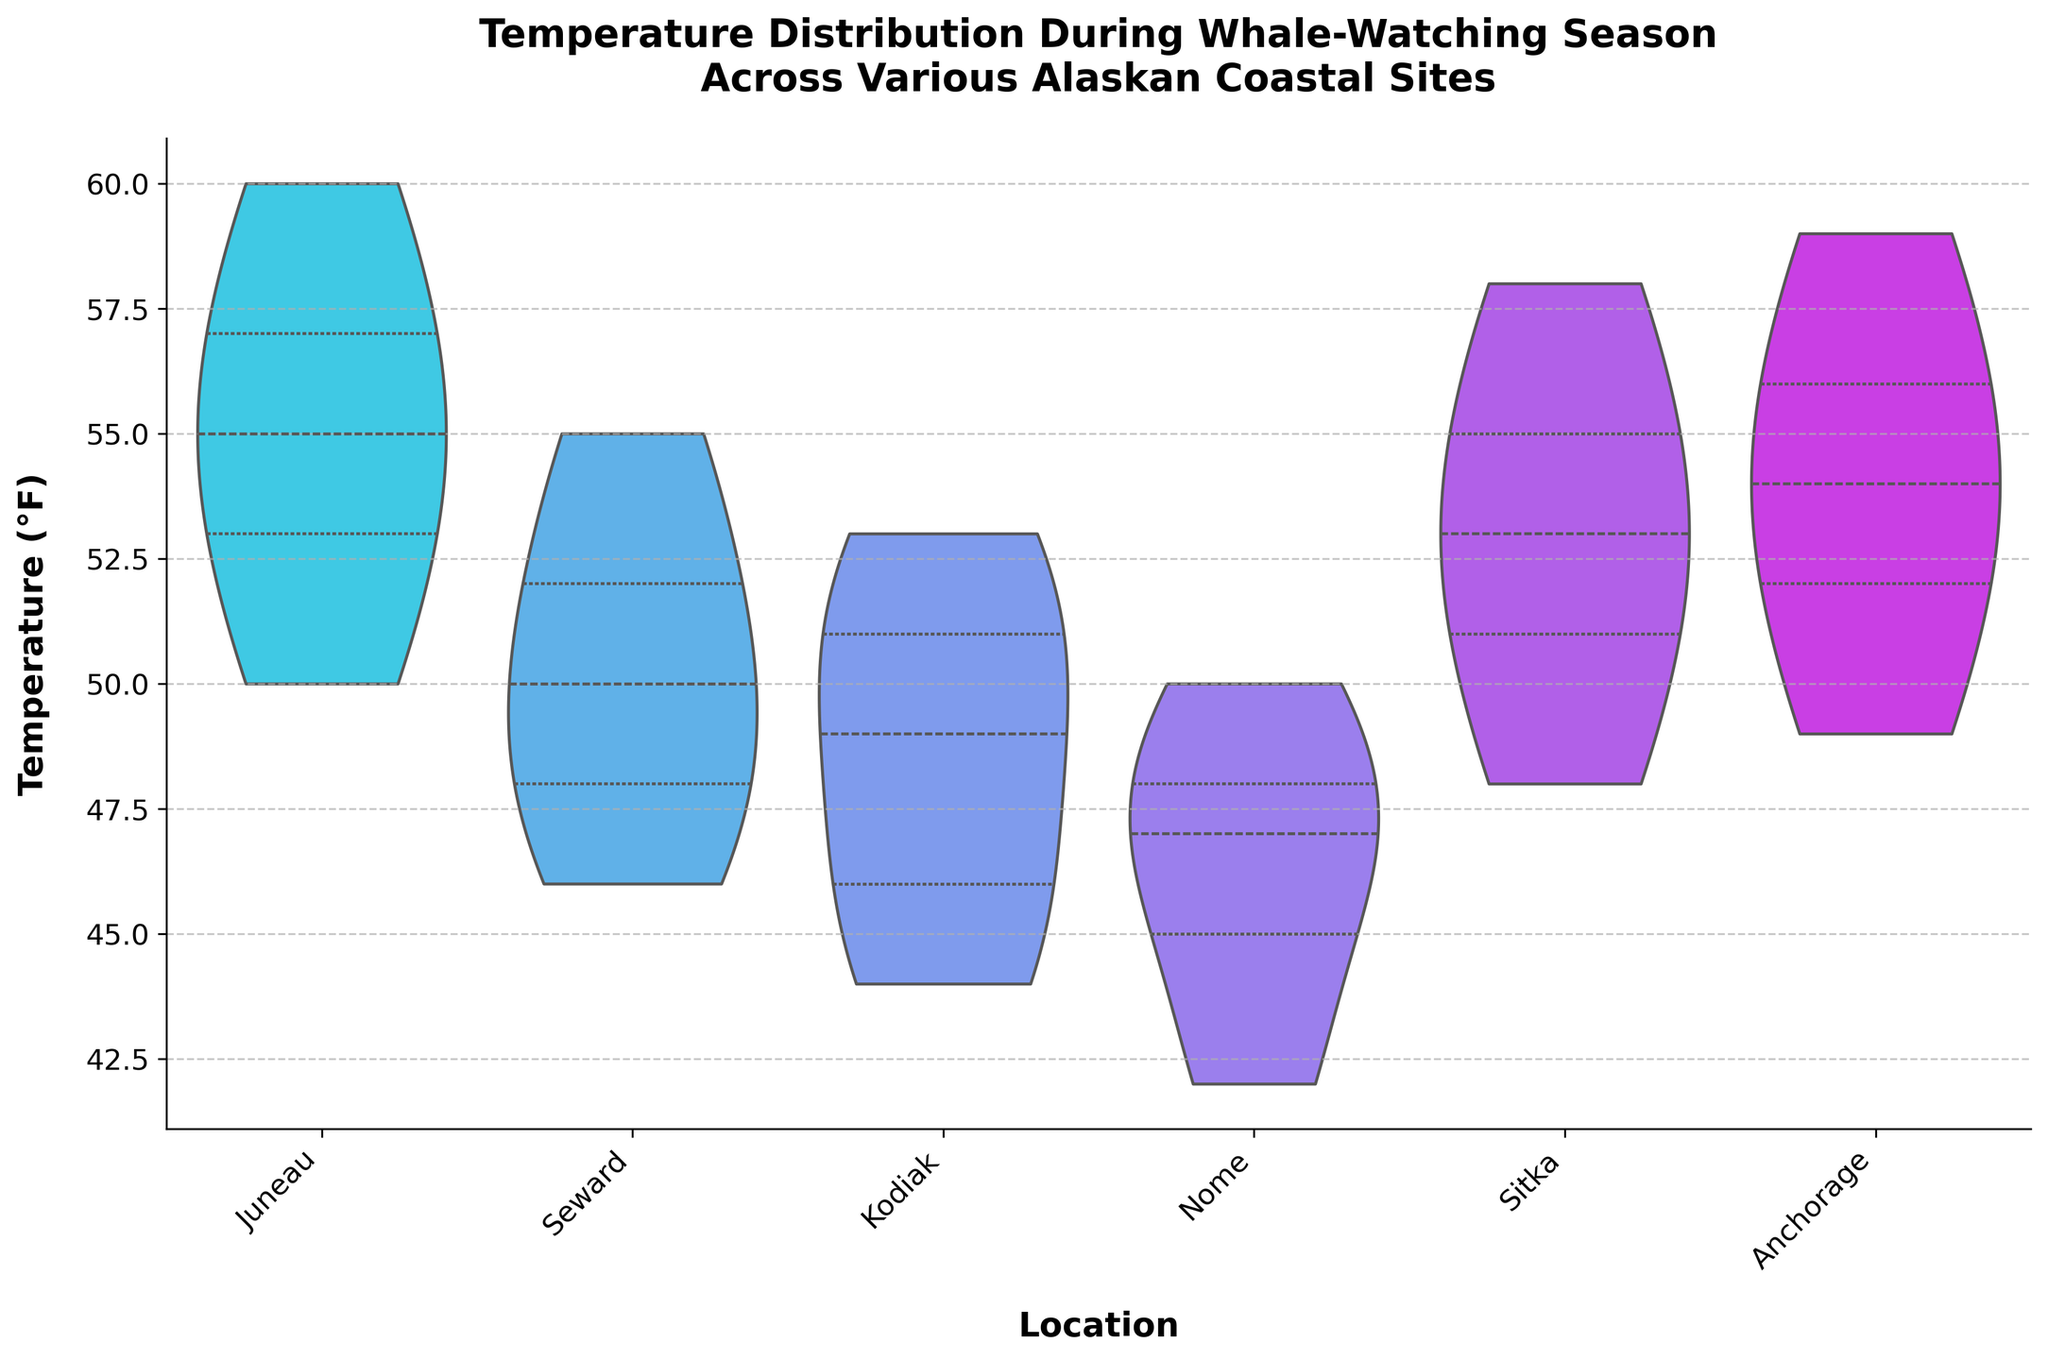What is the title of the violin chart? The title of the violin chart is displayed at the top of the figure, usually in a larger and bolder font. It gives you the main subject of the chart.
Answer: Temperature Distribution During Whale-Watching Season Across Various Alaskan Coastal Sites Which location shows the highest median temperature? In a violin plot, the median is typically indicated by a line within the inner quartile range. By identifying the highest line among the locations, you can find the location with the highest median temperature.
Answer: Juneau What is the temperature range for Kodiak? The violin plot shows the distribution of temperatures along the y-axis. The top and bottom of the distribution for Kodiak indicate the highest and lowest temperatures, respectively.
Answer: 44°F to 53°F Which location has the widest spread in temperature distribution? The spread in a violin plot is represented by the width of the shaded area. The location with the widest section of the violin plot indicates the largest spread.
Answer: Juneau Are the temperatures in Nome higher than those in Seward? To compare temperatures, examine the distributions for both Nome and Seward. By evaluating their ranges on the y-axis, you can determine if one generally has higher temperatures than the other.
Answer: No How does the temperature distribution in Anchorage compare to Sitka? This involves comparing two distributions side-by-side. Look at the shape, spread, and central tendencies of both Anchorage and Sitka to interpret their similarities and differences.
Answer: Similar, but Anchorage has a slightly higher range Which location has the smallest interquartile range (IQR)? The IQR is indicated by the area between the first and third quartiles in a violin plot. The location with the smallest distance between these quartiles has the smallest IQR.
Answer: Sitka What is the median temperature in Seward? Locate the median line within the box of the violin plot for Seward. This line represents the median temperature value.
Answer: 50°F How does the temperature variability in Nome differ from Juneau? Evaluate the width and shape of the distributions for both Nome and Juneau. Wider and more diffuse shapes indicate greater variability.
Answer: Nome has less variability compared to Juneau What can be inferred about whale-watching conditions based on these temperatures? Higher temperatures might suggest more comfortable whale-watching conditions. Interpret the overall temperature ranges to provide insights into which locations might offer better weather conditions for whale-watching.
Answer: Juneau and Sitka likely offer warmer and possibly more comfortable conditions 